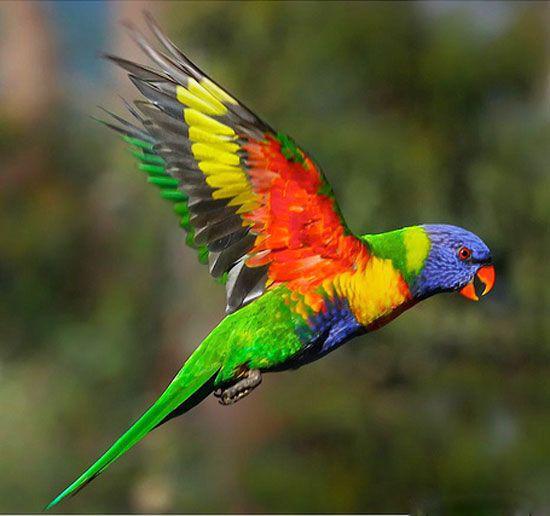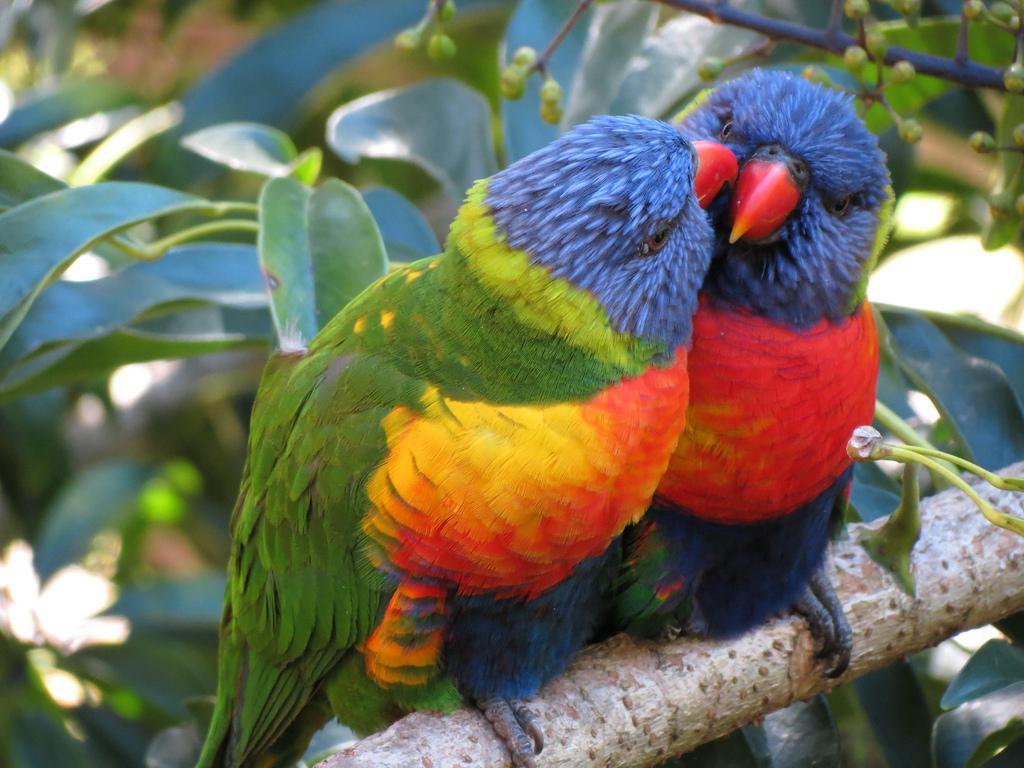The first image is the image on the left, the second image is the image on the right. Analyze the images presented: Is the assertion "At least one image shows a colorful bird with its wings spread" valid? Answer yes or no. Yes. The first image is the image on the left, the second image is the image on the right. Evaluate the accuracy of this statement regarding the images: "There are four birds perched together in groups of two.". Is it true? Answer yes or no. No. 